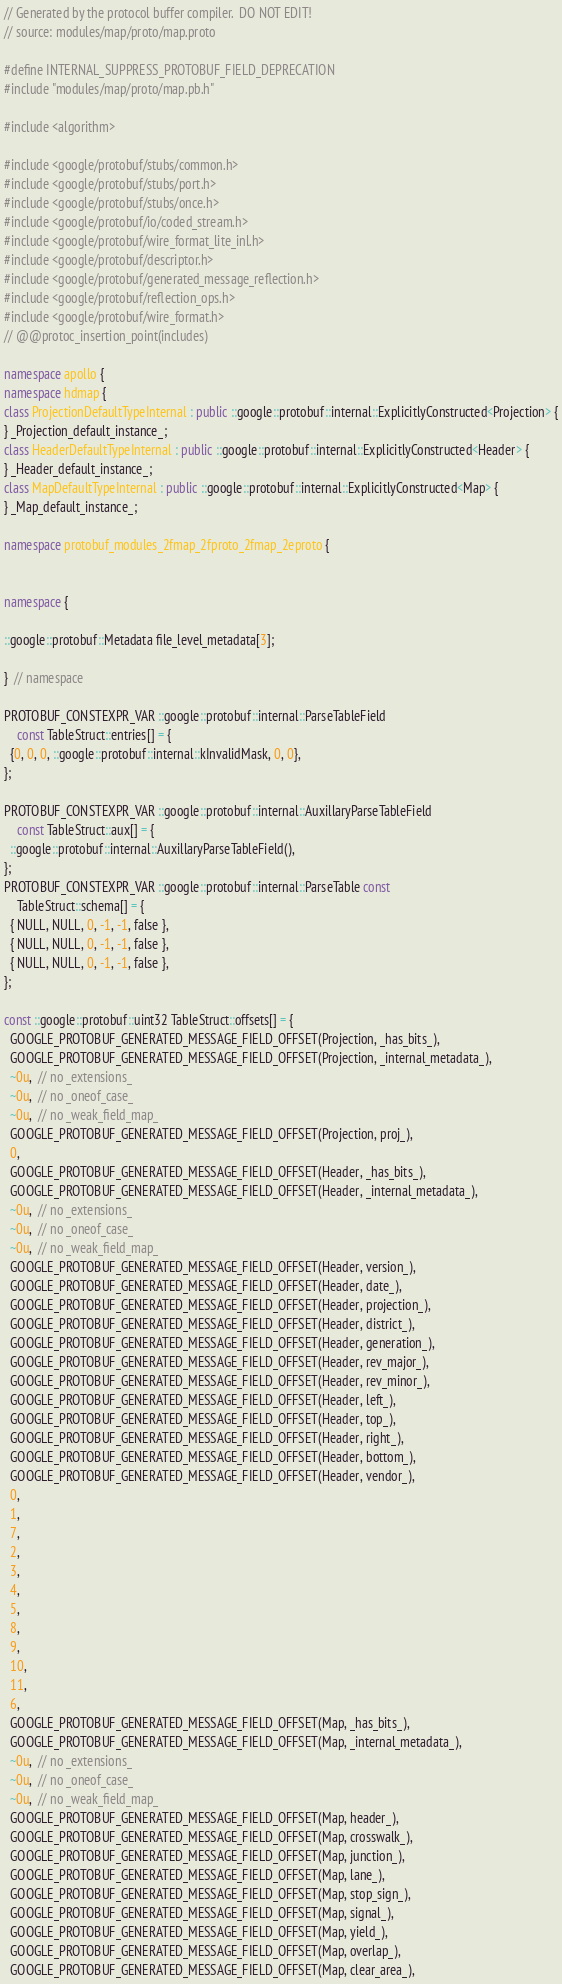<code> <loc_0><loc_0><loc_500><loc_500><_C++_>// Generated by the protocol buffer compiler.  DO NOT EDIT!
// source: modules/map/proto/map.proto

#define INTERNAL_SUPPRESS_PROTOBUF_FIELD_DEPRECATION
#include "modules/map/proto/map.pb.h"

#include <algorithm>

#include <google/protobuf/stubs/common.h>
#include <google/protobuf/stubs/port.h>
#include <google/protobuf/stubs/once.h>
#include <google/protobuf/io/coded_stream.h>
#include <google/protobuf/wire_format_lite_inl.h>
#include <google/protobuf/descriptor.h>
#include <google/protobuf/generated_message_reflection.h>
#include <google/protobuf/reflection_ops.h>
#include <google/protobuf/wire_format.h>
// @@protoc_insertion_point(includes)

namespace apollo {
namespace hdmap {
class ProjectionDefaultTypeInternal : public ::google::protobuf::internal::ExplicitlyConstructed<Projection> {
} _Projection_default_instance_;
class HeaderDefaultTypeInternal : public ::google::protobuf::internal::ExplicitlyConstructed<Header> {
} _Header_default_instance_;
class MapDefaultTypeInternal : public ::google::protobuf::internal::ExplicitlyConstructed<Map> {
} _Map_default_instance_;

namespace protobuf_modules_2fmap_2fproto_2fmap_2eproto {


namespace {

::google::protobuf::Metadata file_level_metadata[3];

}  // namespace

PROTOBUF_CONSTEXPR_VAR ::google::protobuf::internal::ParseTableField
    const TableStruct::entries[] = {
  {0, 0, 0, ::google::protobuf::internal::kInvalidMask, 0, 0},
};

PROTOBUF_CONSTEXPR_VAR ::google::protobuf::internal::AuxillaryParseTableField
    const TableStruct::aux[] = {
  ::google::protobuf::internal::AuxillaryParseTableField(),
};
PROTOBUF_CONSTEXPR_VAR ::google::protobuf::internal::ParseTable const
    TableStruct::schema[] = {
  { NULL, NULL, 0, -1, -1, false },
  { NULL, NULL, 0, -1, -1, false },
  { NULL, NULL, 0, -1, -1, false },
};

const ::google::protobuf::uint32 TableStruct::offsets[] = {
  GOOGLE_PROTOBUF_GENERATED_MESSAGE_FIELD_OFFSET(Projection, _has_bits_),
  GOOGLE_PROTOBUF_GENERATED_MESSAGE_FIELD_OFFSET(Projection, _internal_metadata_),
  ~0u,  // no _extensions_
  ~0u,  // no _oneof_case_
  ~0u,  // no _weak_field_map_
  GOOGLE_PROTOBUF_GENERATED_MESSAGE_FIELD_OFFSET(Projection, proj_),
  0,
  GOOGLE_PROTOBUF_GENERATED_MESSAGE_FIELD_OFFSET(Header, _has_bits_),
  GOOGLE_PROTOBUF_GENERATED_MESSAGE_FIELD_OFFSET(Header, _internal_metadata_),
  ~0u,  // no _extensions_
  ~0u,  // no _oneof_case_
  ~0u,  // no _weak_field_map_
  GOOGLE_PROTOBUF_GENERATED_MESSAGE_FIELD_OFFSET(Header, version_),
  GOOGLE_PROTOBUF_GENERATED_MESSAGE_FIELD_OFFSET(Header, date_),
  GOOGLE_PROTOBUF_GENERATED_MESSAGE_FIELD_OFFSET(Header, projection_),
  GOOGLE_PROTOBUF_GENERATED_MESSAGE_FIELD_OFFSET(Header, district_),
  GOOGLE_PROTOBUF_GENERATED_MESSAGE_FIELD_OFFSET(Header, generation_),
  GOOGLE_PROTOBUF_GENERATED_MESSAGE_FIELD_OFFSET(Header, rev_major_),
  GOOGLE_PROTOBUF_GENERATED_MESSAGE_FIELD_OFFSET(Header, rev_minor_),
  GOOGLE_PROTOBUF_GENERATED_MESSAGE_FIELD_OFFSET(Header, left_),
  GOOGLE_PROTOBUF_GENERATED_MESSAGE_FIELD_OFFSET(Header, top_),
  GOOGLE_PROTOBUF_GENERATED_MESSAGE_FIELD_OFFSET(Header, right_),
  GOOGLE_PROTOBUF_GENERATED_MESSAGE_FIELD_OFFSET(Header, bottom_),
  GOOGLE_PROTOBUF_GENERATED_MESSAGE_FIELD_OFFSET(Header, vendor_),
  0,
  1,
  7,
  2,
  3,
  4,
  5,
  8,
  9,
  10,
  11,
  6,
  GOOGLE_PROTOBUF_GENERATED_MESSAGE_FIELD_OFFSET(Map, _has_bits_),
  GOOGLE_PROTOBUF_GENERATED_MESSAGE_FIELD_OFFSET(Map, _internal_metadata_),
  ~0u,  // no _extensions_
  ~0u,  // no _oneof_case_
  ~0u,  // no _weak_field_map_
  GOOGLE_PROTOBUF_GENERATED_MESSAGE_FIELD_OFFSET(Map, header_),
  GOOGLE_PROTOBUF_GENERATED_MESSAGE_FIELD_OFFSET(Map, crosswalk_),
  GOOGLE_PROTOBUF_GENERATED_MESSAGE_FIELD_OFFSET(Map, junction_),
  GOOGLE_PROTOBUF_GENERATED_MESSAGE_FIELD_OFFSET(Map, lane_),
  GOOGLE_PROTOBUF_GENERATED_MESSAGE_FIELD_OFFSET(Map, stop_sign_),
  GOOGLE_PROTOBUF_GENERATED_MESSAGE_FIELD_OFFSET(Map, signal_),
  GOOGLE_PROTOBUF_GENERATED_MESSAGE_FIELD_OFFSET(Map, yield_),
  GOOGLE_PROTOBUF_GENERATED_MESSAGE_FIELD_OFFSET(Map, overlap_),
  GOOGLE_PROTOBUF_GENERATED_MESSAGE_FIELD_OFFSET(Map, clear_area_),</code> 